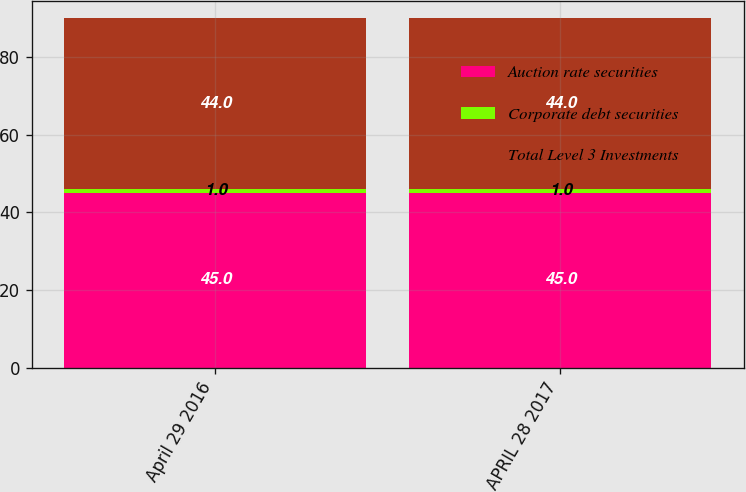<chart> <loc_0><loc_0><loc_500><loc_500><stacked_bar_chart><ecel><fcel>April 29 2016<fcel>APRIL 28 2017<nl><fcel>Auction rate securities<fcel>45<fcel>45<nl><fcel>Corporate debt securities<fcel>1<fcel>1<nl><fcel>Total Level 3 Investments<fcel>44<fcel>44<nl></chart> 